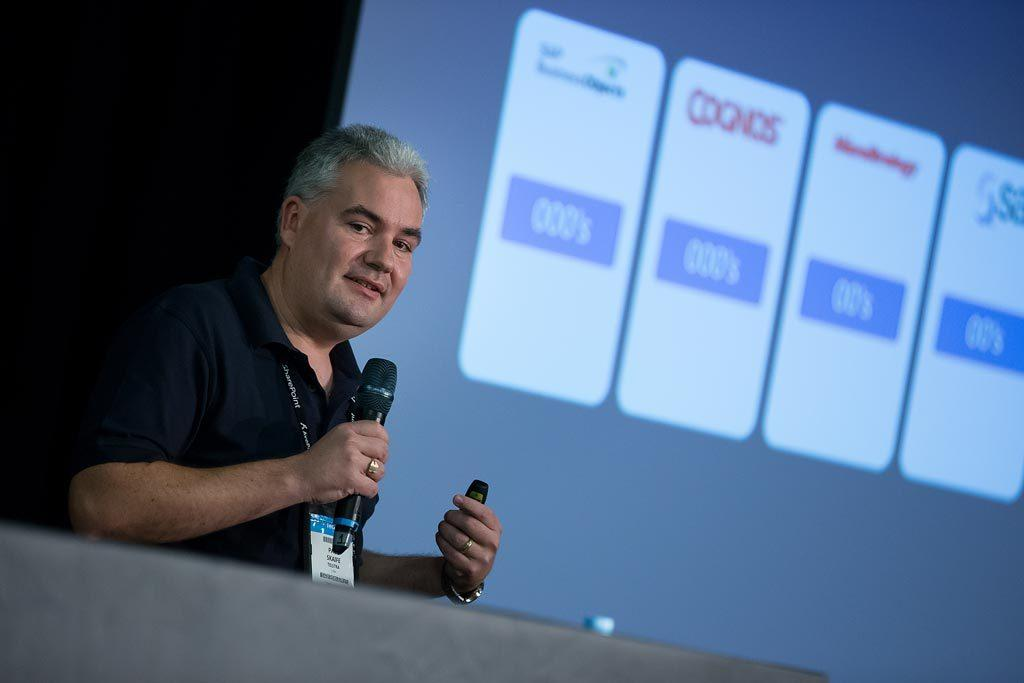What is the person in the image doing? The person is holding a mic. What might the person be using the mic for? The person might be using the mic for speaking or singing. What can be seen in the background of the image? There is a projector screen in the background of the image. What is displayed on the projector screen? Text is visible on the projector screen. What type of holiday is being celebrated in the image? There is no indication of a holiday being celebrated in the image. What kind of doll is sitting on the projector screen? There is no doll present in the image. 